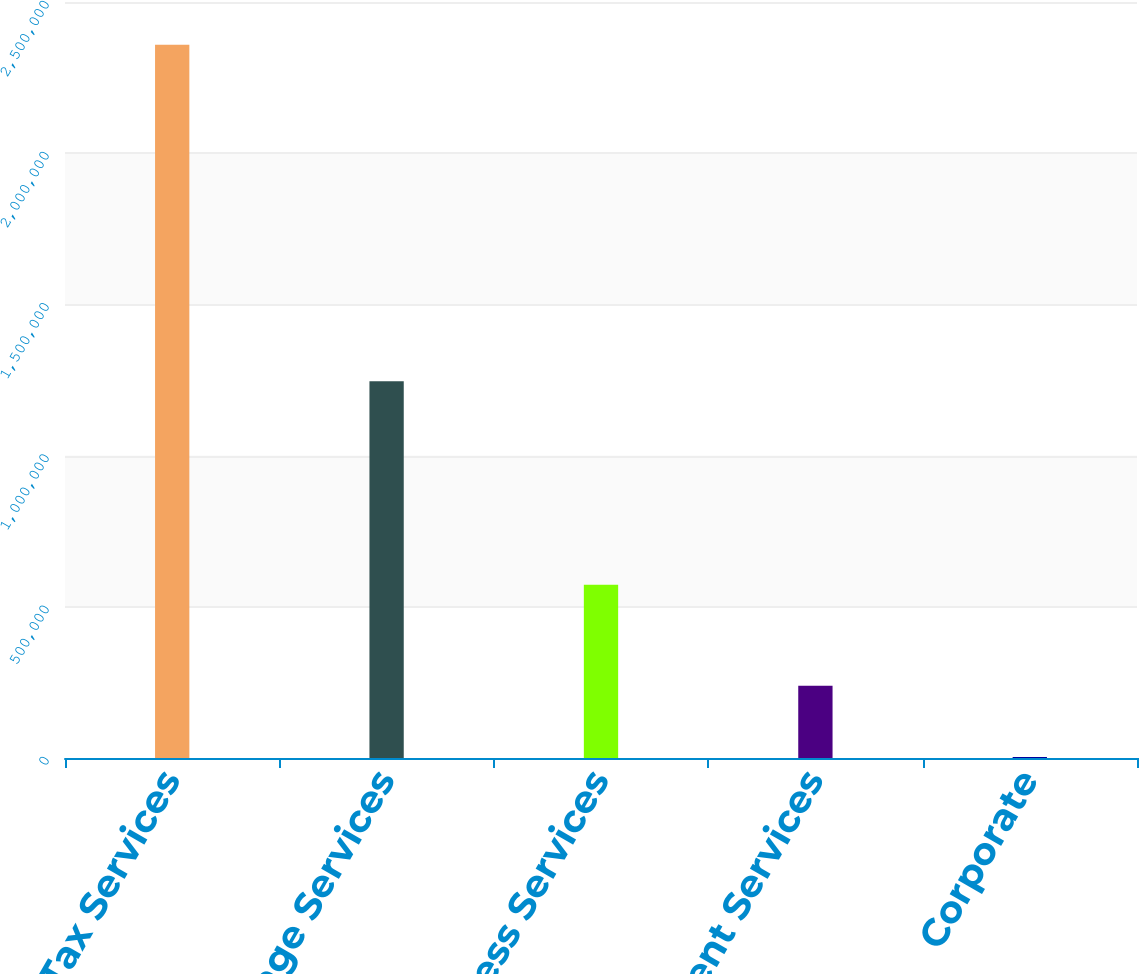Convert chart. <chart><loc_0><loc_0><loc_500><loc_500><bar_chart><fcel>Tax Services<fcel>Mortgage Services<fcel>Business Services<fcel>Investment Services<fcel>Corporate<nl><fcel>2.35829e+06<fcel>1.24602e+06<fcel>573316<fcel>239244<fcel>3148<nl></chart> 